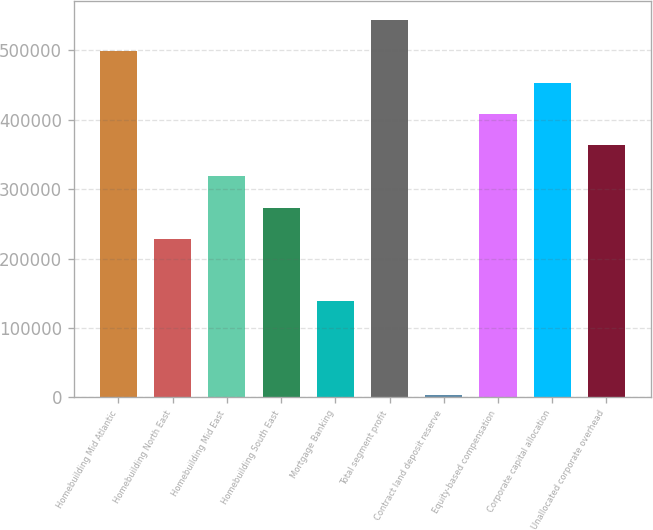Convert chart to OTSL. <chart><loc_0><loc_0><loc_500><loc_500><bar_chart><fcel>Homebuilding Mid Atlantic<fcel>Homebuilding North East<fcel>Homebuilding Mid East<fcel>Homebuilding South East<fcel>Mortgage Banking<fcel>Total segment profit<fcel>Contract land deposit reserve<fcel>Equity-based compensation<fcel>Corporate capital allocation<fcel>Unallocated corporate overhead<nl><fcel>498539<fcel>228579<fcel>318566<fcel>273572<fcel>138592<fcel>543533<fcel>3612<fcel>408553<fcel>453546<fcel>363559<nl></chart> 